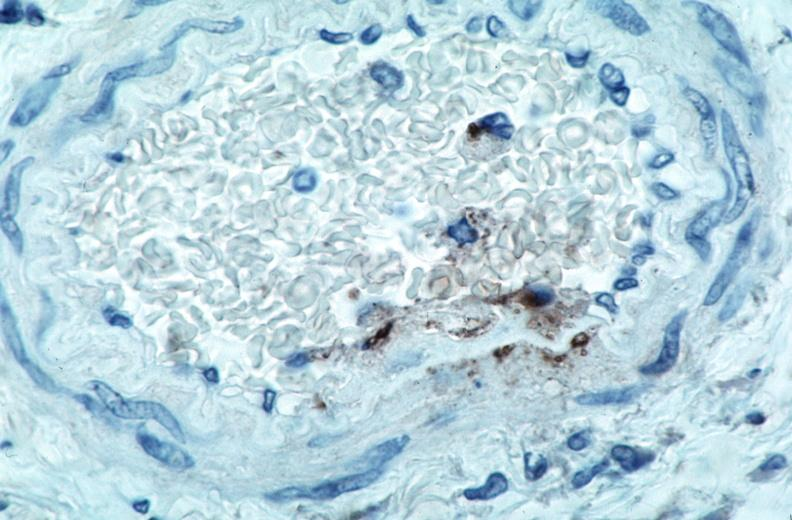what is rocky mountain spotted?
Answer the question using a single word or phrase. Fever 